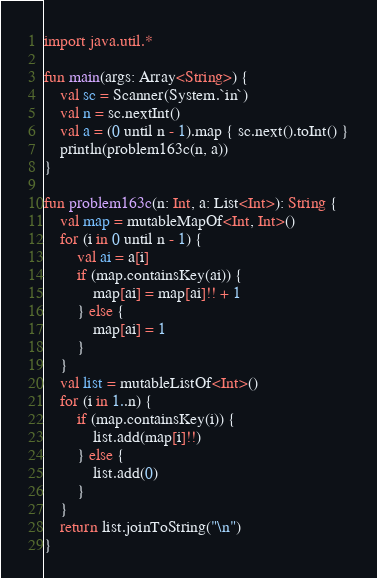<code> <loc_0><loc_0><loc_500><loc_500><_Kotlin_>import java.util.*

fun main(args: Array<String>) {
    val sc = Scanner(System.`in`)
    val n = sc.nextInt()
    val a = (0 until n - 1).map { sc.next().toInt() }
    println(problem163c(n, a))
}

fun problem163c(n: Int, a: List<Int>): String {
    val map = mutableMapOf<Int, Int>()
    for (i in 0 until n - 1) {
        val ai = a[i]
        if (map.containsKey(ai)) {
            map[ai] = map[ai]!! + 1
        } else {
            map[ai] = 1
        }
    }
    val list = mutableListOf<Int>()
    for (i in 1..n) {
        if (map.containsKey(i)) {
            list.add(map[i]!!)
        } else {
            list.add(0)
        }
    }
    return list.joinToString("\n")
}</code> 